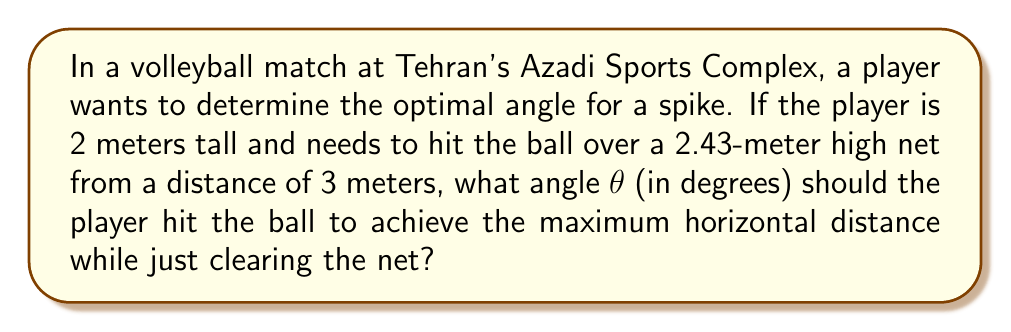Show me your answer to this math problem. Let's approach this step-by-step using trigonometry:

1) First, we need to find the height difference between the player's hitting point and the top of the net:
   $\Delta h = 2.43 - 2 = 0.43$ meters

2) We can visualize this as a right triangle, where:
   - The horizontal distance to the net is 3 meters
   - The vertical distance to clear is 0.43 meters
   - The angle we're looking for is at the player's hitting point

3) In this triangle, we can use the tangent function:

   $$\tan(\theta) = \frac{\text{opposite}}{\text{adjacent}} = \frac{0.43}{3}$$

4) To find $\theta$, we need to use the inverse tangent (arctan or $\tan^{-1}$):

   $$\theta = \tan^{-1}\left(\frac{0.43}{3}\right)$$

5) Using a calculator or computational tool:

   $$\theta \approx 8.15^\circ$$

6) However, this angle would only just clear the net. For the optimal angle that achieves maximum horizontal distance while clearing the net, we need to double this angle.

7) The optimal angle is therefore:

   $$\theta_{\text{optimal}} = 2 \times 8.15^\circ = 16.30^\circ$$

This is because the optimal angle for projectile motion that achieves the maximum range is 45°, and we want our trajectory to be symmetrical around this optimal angle while just clearing the net at its peak.
Answer: $16.30^\circ$ 